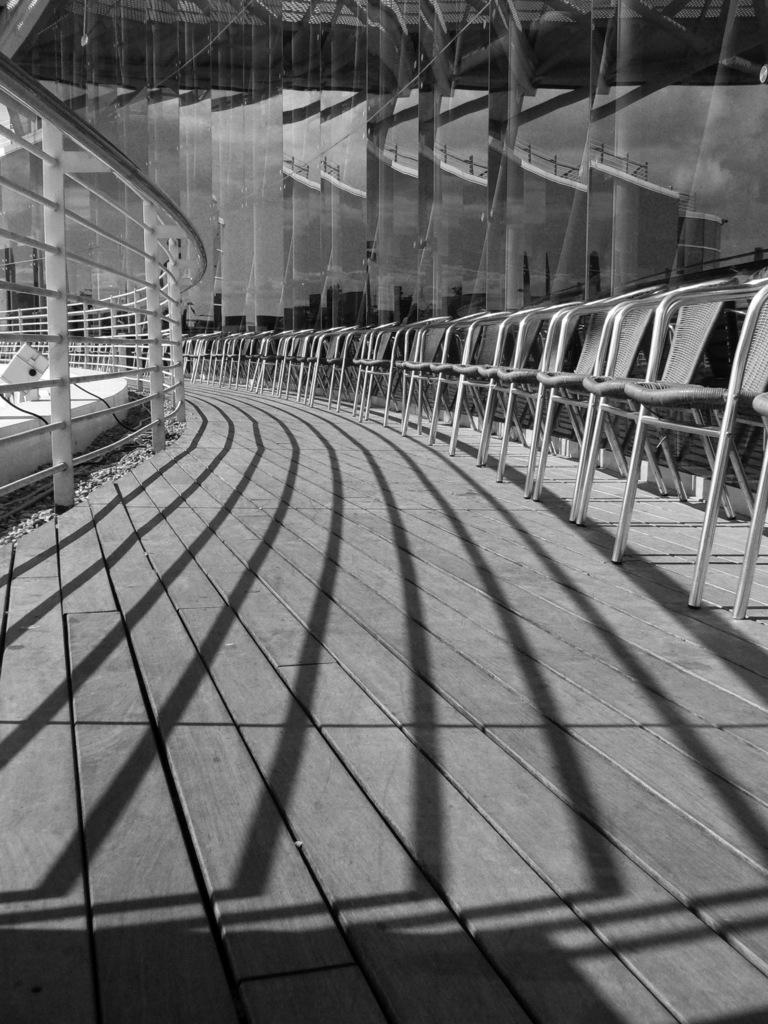What type of structure is visible in the image? There is a building in the image. What furniture can be seen on the right side of the image? There are chairs on the right side of the image. What architectural feature is present on the left side of the image? There is a balcony on the left side of the image. What material is used for the floor at the bottom of the image? The floor at the bottom of the image is made up of wood. What type of cabbage is being used to write on the balcony in the image? There is no cabbage present in the image, and it is not being used to write on the balcony. 